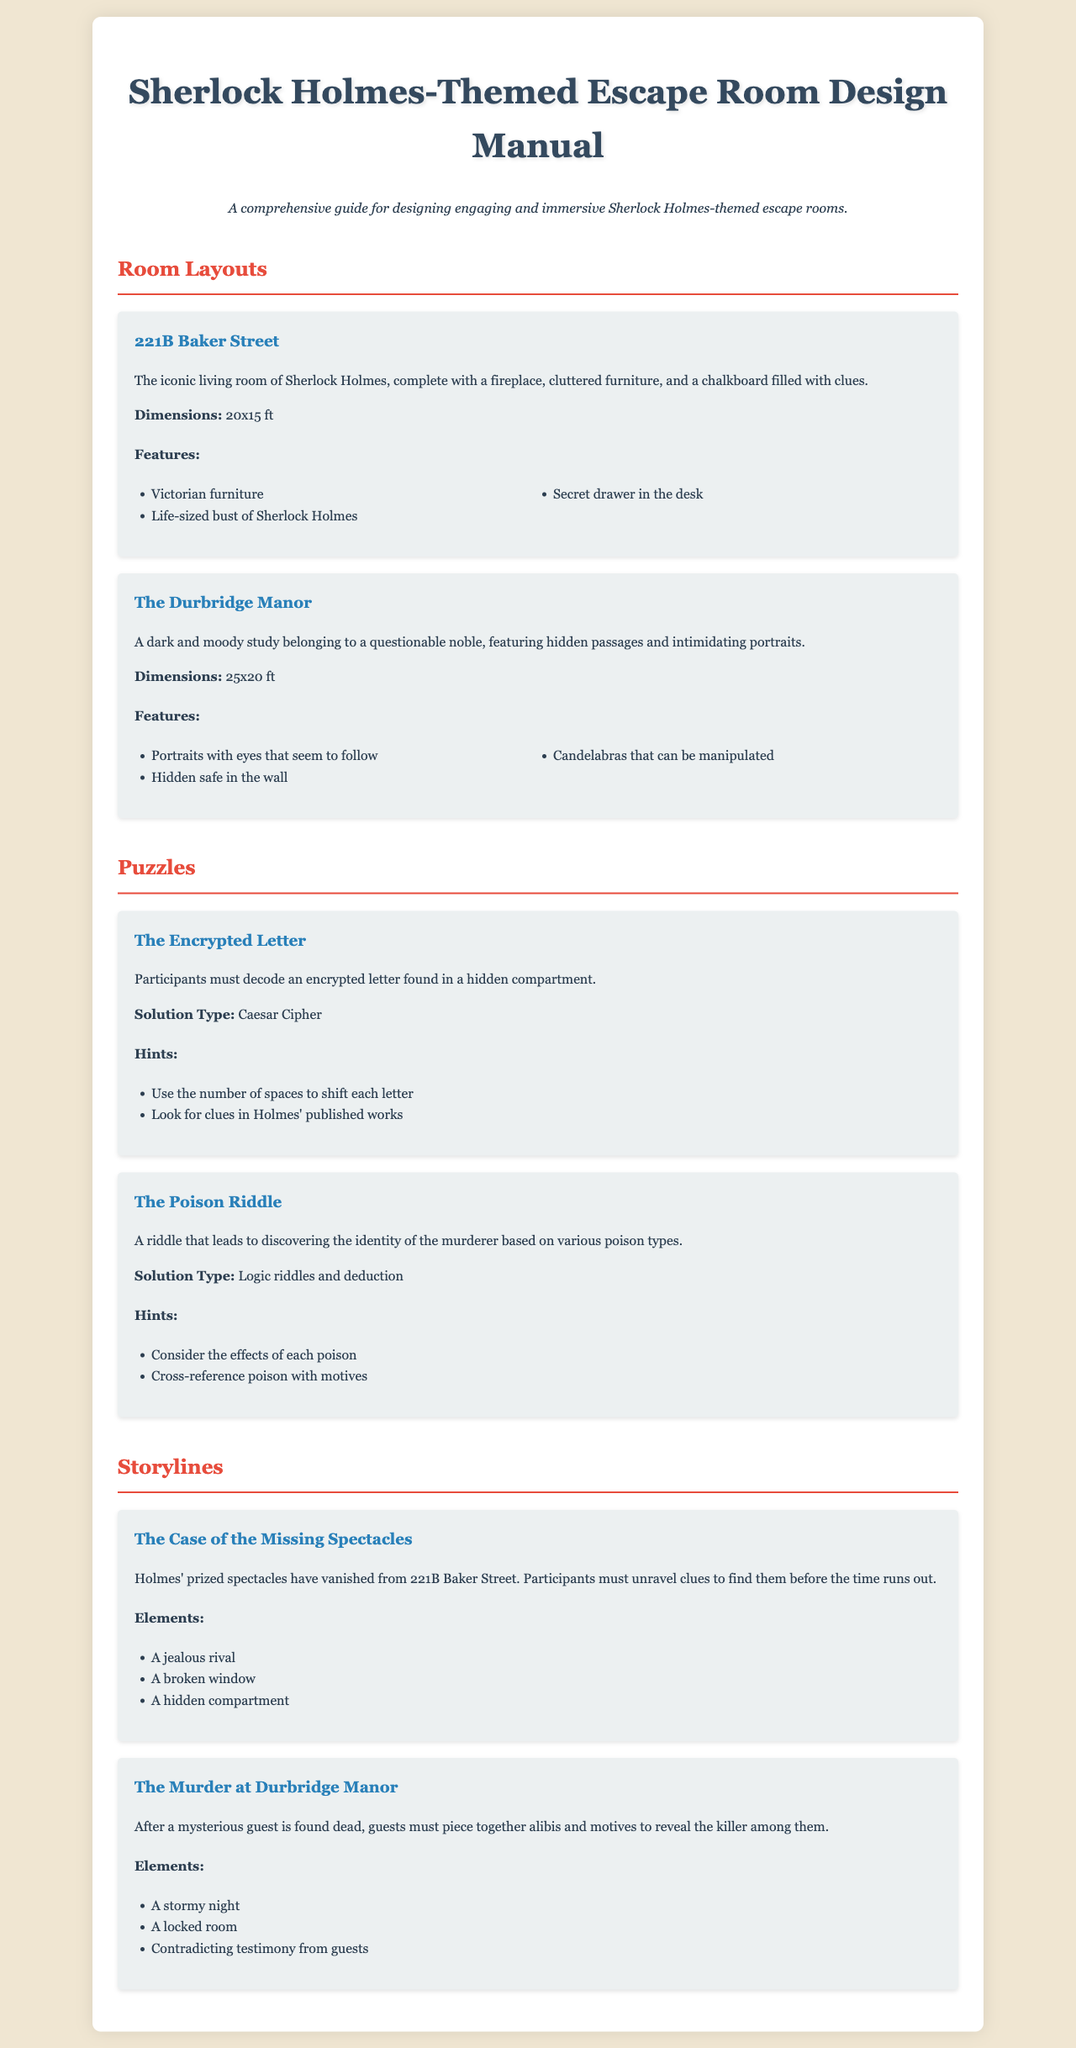what are the dimensions of 221B Baker Street? The dimensions of the room are stated in the document as 20x15 ft.
Answer: 20x15 ft what is the title of the first puzzle? The first puzzle is named "The Encrypted Letter".
Answer: The Encrypted Letter which storyline involves a locked room? The storyline that involves a locked room is "The Murder at Durbridge Manor".
Answer: The Murder at Durbridge Manor how many features are listed for The Durbridge Manor? The document lists three features for The Durbridge Manor.
Answer: 3 what is the solution type for The Poison Riddle? The solution type for The Poison Riddle is mentioned as "Logic riddles and deduction".
Answer: Logic riddles and deduction what is an element of "The Case of the Missing Spectacles"? One of the elements is "A jealous rival".
Answer: A jealous rival how many rooms are detailed in the manual? The manual details two rooms, 221B Baker Street and The Durbridge Manor.
Answer: 2 what type of cipher is used in the first puzzle? The type of cipher used is a "Caesar Cipher."
Answer: Caesar Cipher what is the description of the room layout for 221B Baker Street? The description states that it is "The iconic living room of Sherlock Holmes, complete with a fireplace, cluttered furniture, and a chalkboard filled with clues."
Answer: The iconic living room of Sherlock Holmes, complete with a fireplace, cluttered furniture, and a chalkboard filled with clues 